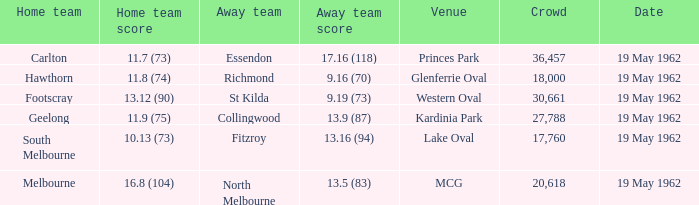What is the home team's score at mcg? 16.8 (104). 